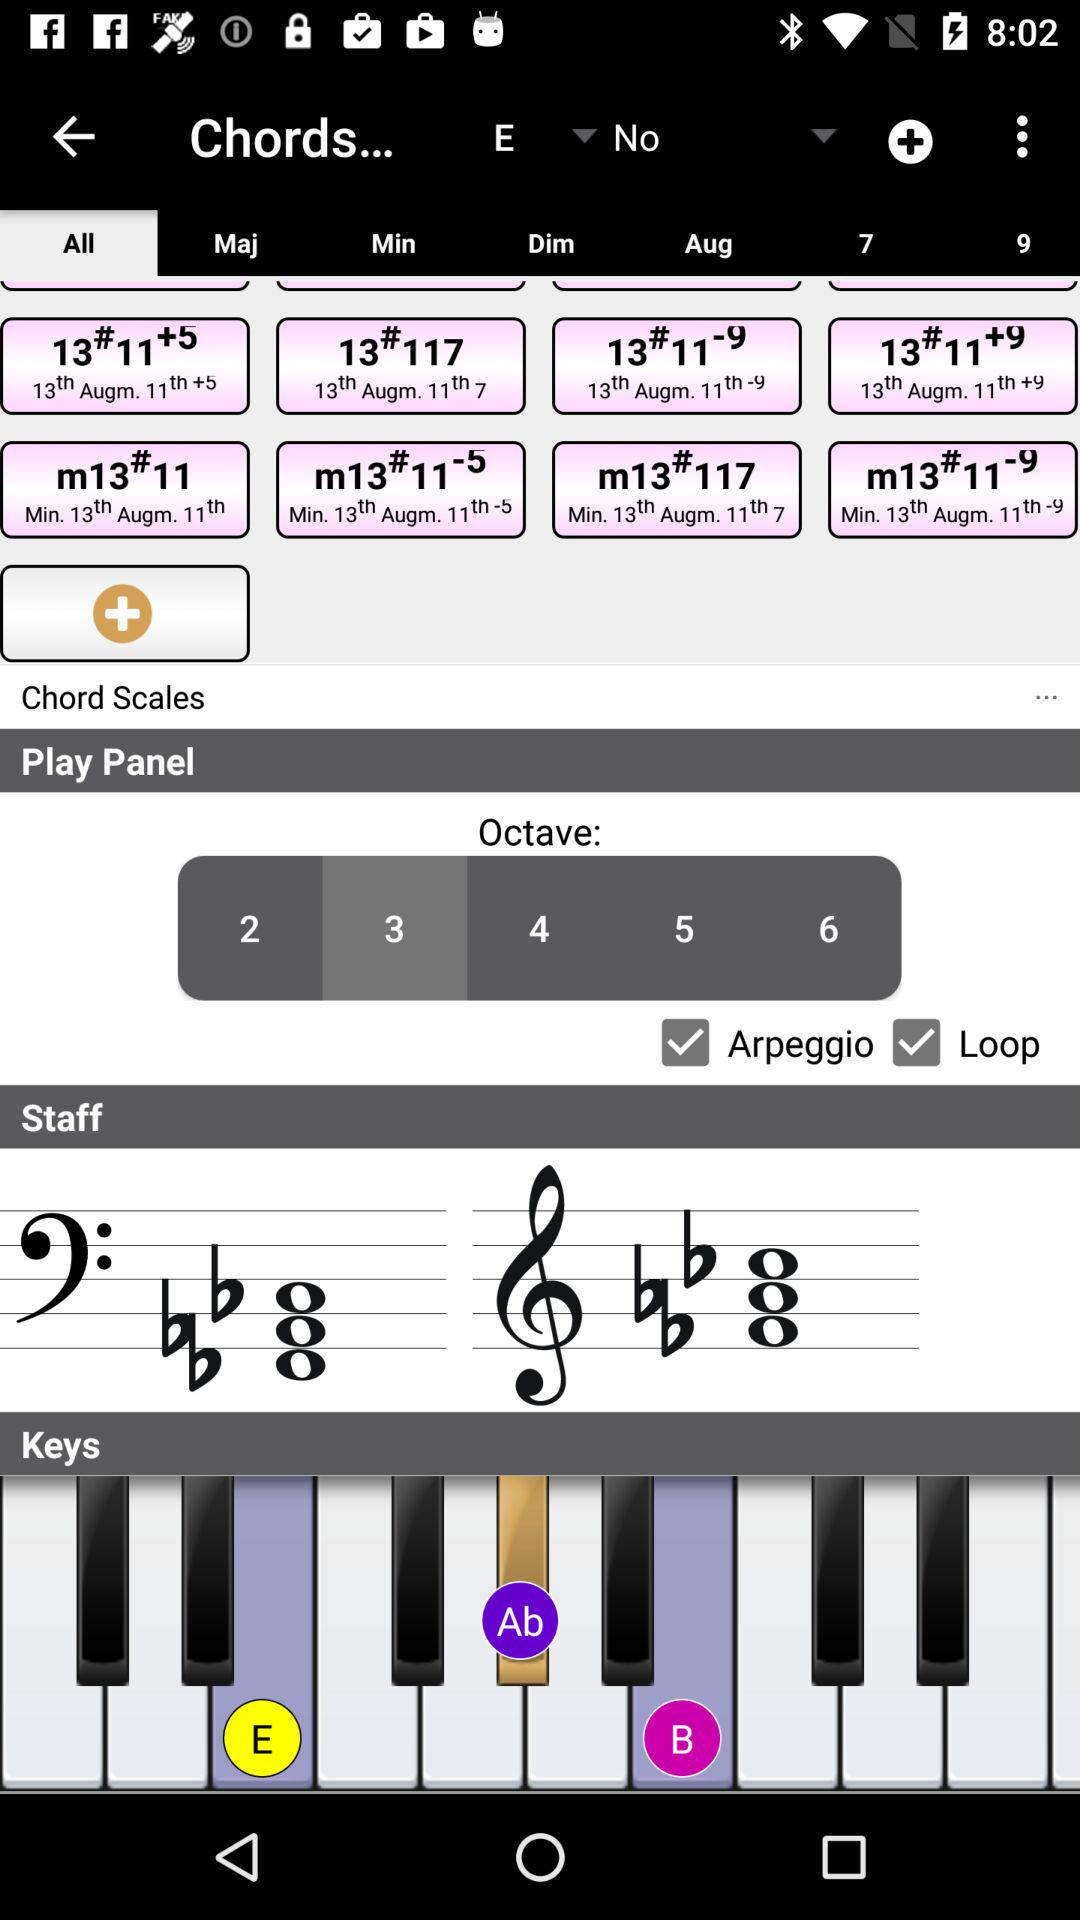What is the status of "Loop"? The status is "on". 